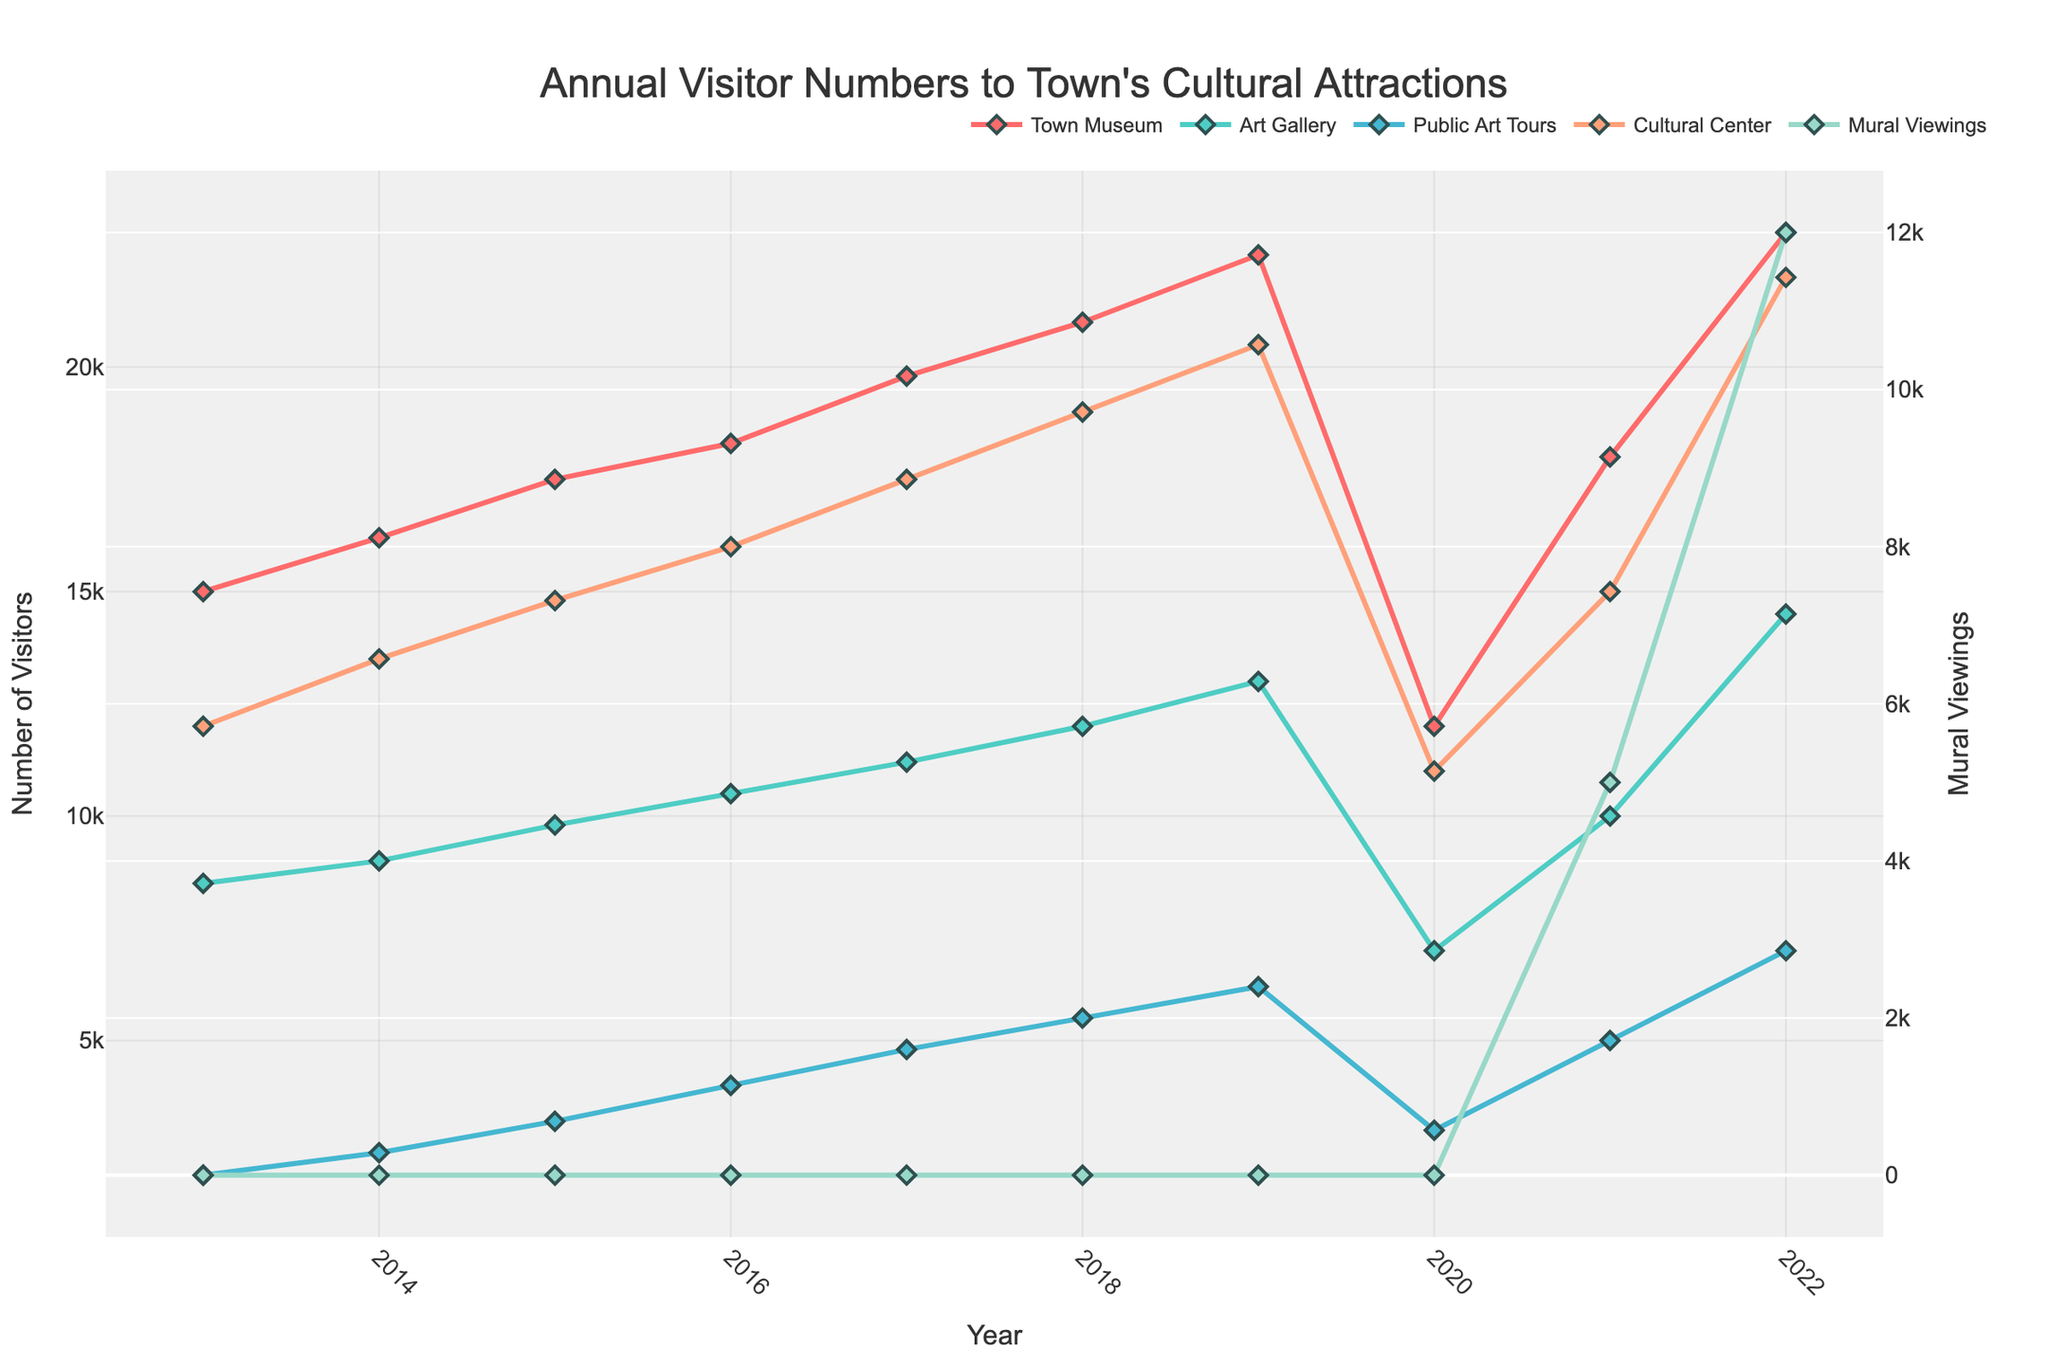Which year saw the highest number of visitors to the Town Museum? The highest point on the line representing the Town Museum corresponds to the year 2022.
Answer: 2022 How did the number of visitors to the Art Gallery change from 2020 to 2022? The number of visitors increased from 7000 in 2020 to 14500 in 2022.
Answer: Increased By how many visitors did the Cultural Center attendance increase from 2013 to 2019? The number of visitors increased from 12000 in 2013 to 20500 in 2019. The difference is 20500 - 12000 = 8500.
Answer: 8500 Compare the number of visitors to Public Art Tours and Mural Viewings in 2022. Which had more, and by how much? In 2022, Public Art Tours had 7000 visitors and Mural Viewings had 12000 visitors. The difference is 12000 - 7000 = 5000.
Answer: Mural Viewings, 5000 more What was the trend for the Town Museum visitors from 2013 to 2022? The trend shows a general increase from 15000 in 2013 to 23000 in 2022, with a noticeable drop in 2020 to 12000 before recovering in 2021.
Answer: Generally Increasing Which cultural attraction had the lowest number of visitors in 2017, and what was that number? In 2017, the lowest number of visitors was to Public Art Tours, with 4800 visitors.
Answer: Public Art Tours, 4800 In which year did Mural Viewings start getting recorded, and what was the initial number of visitors? Mural Viewings started getting recorded in 2021 with the initial number of visitors being 5000.
Answer: 2021, 5000 Did any cultural attraction experience a drop in visitors from 2019 to 2020, and if so, by how much? All attractions experienced a drop from 2019 to 2020. The Town Museum dropped from 22500 to 12000 (a decrease of 10500), the Art Gallery from 13000 to 7000 (decrease of 6000), Public Art Tours from 6200 to 3000 (decrease of 3200), and the Cultural Center from 20500 to 11000 (decrease of 9500).
Answer: Yes, all did Compare visitor numbers between the Cultural Center and the Town Museum in 2021. Which had more and by how much? In 2021, the Town Museum had 18000 visitors and the Cultural Center had 15000 visitors. The difference is 18000 - 15000 = 3000.
Answer: Town Museum, 3000 more What is the average number of visitors to the Art Gallery over the decade? The sum of Art Gallery visitors over the decade is 8500 + 9000 + 9800 + 10500 + 11200 + 12000 + 13000 + 7000 + 10000 + 14500 = 104500. There are 10 years, so the average is 104500 / 10 = 10450.
Answer: 10450 